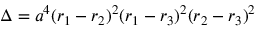<formula> <loc_0><loc_0><loc_500><loc_500>\Delta = a ^ { 4 } ( r _ { 1 } - r _ { 2 } ) ^ { 2 } ( r _ { 1 } - r _ { 3 } ) ^ { 2 } ( r _ { 2 } - r _ { 3 } ) ^ { 2 }</formula> 